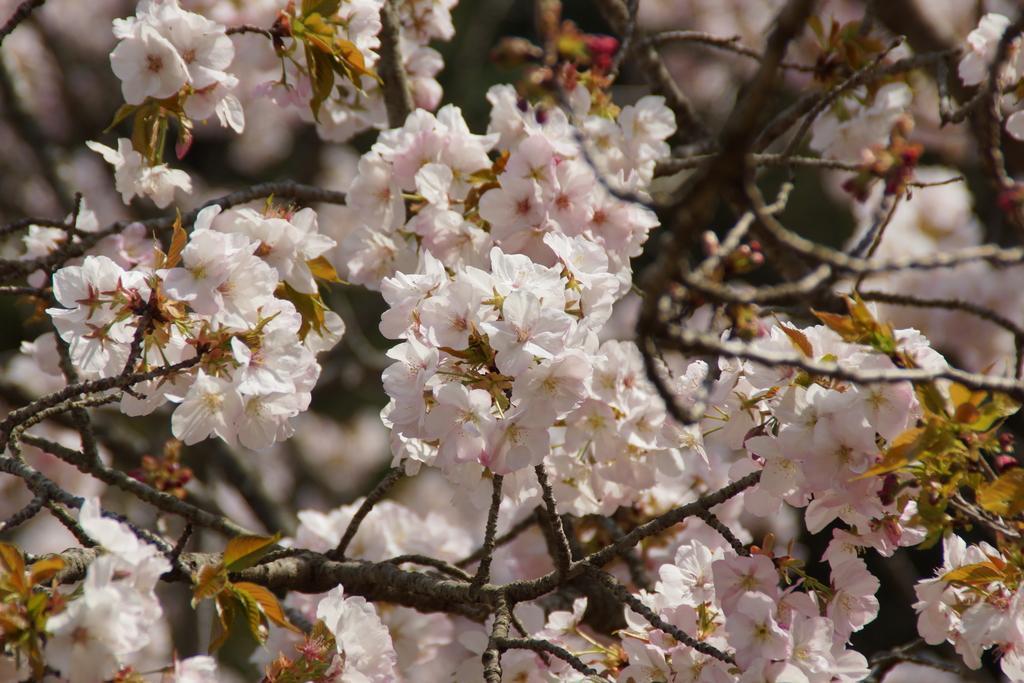In one or two sentences, can you explain what this image depicts? In this image we can see a tree with flowers. In the background the image is blur. 